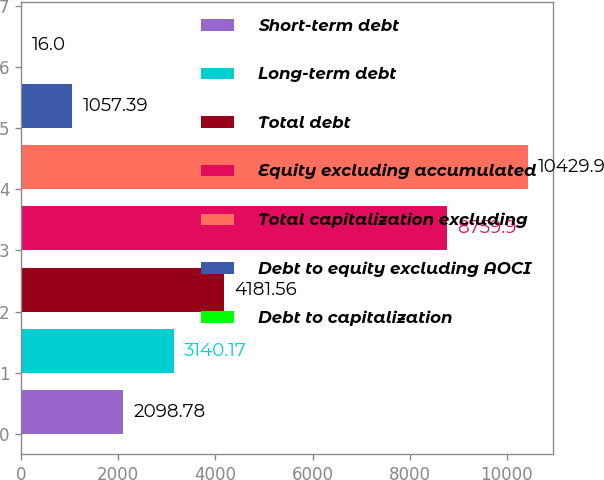Convert chart to OTSL. <chart><loc_0><loc_0><loc_500><loc_500><bar_chart><fcel>Short-term debt<fcel>Long-term debt<fcel>Total debt<fcel>Equity excluding accumulated<fcel>Total capitalization excluding<fcel>Debt to equity excluding AOCI<fcel>Debt to capitalization<nl><fcel>2098.78<fcel>3140.17<fcel>4181.56<fcel>8759.9<fcel>10429.9<fcel>1057.39<fcel>16<nl></chart> 